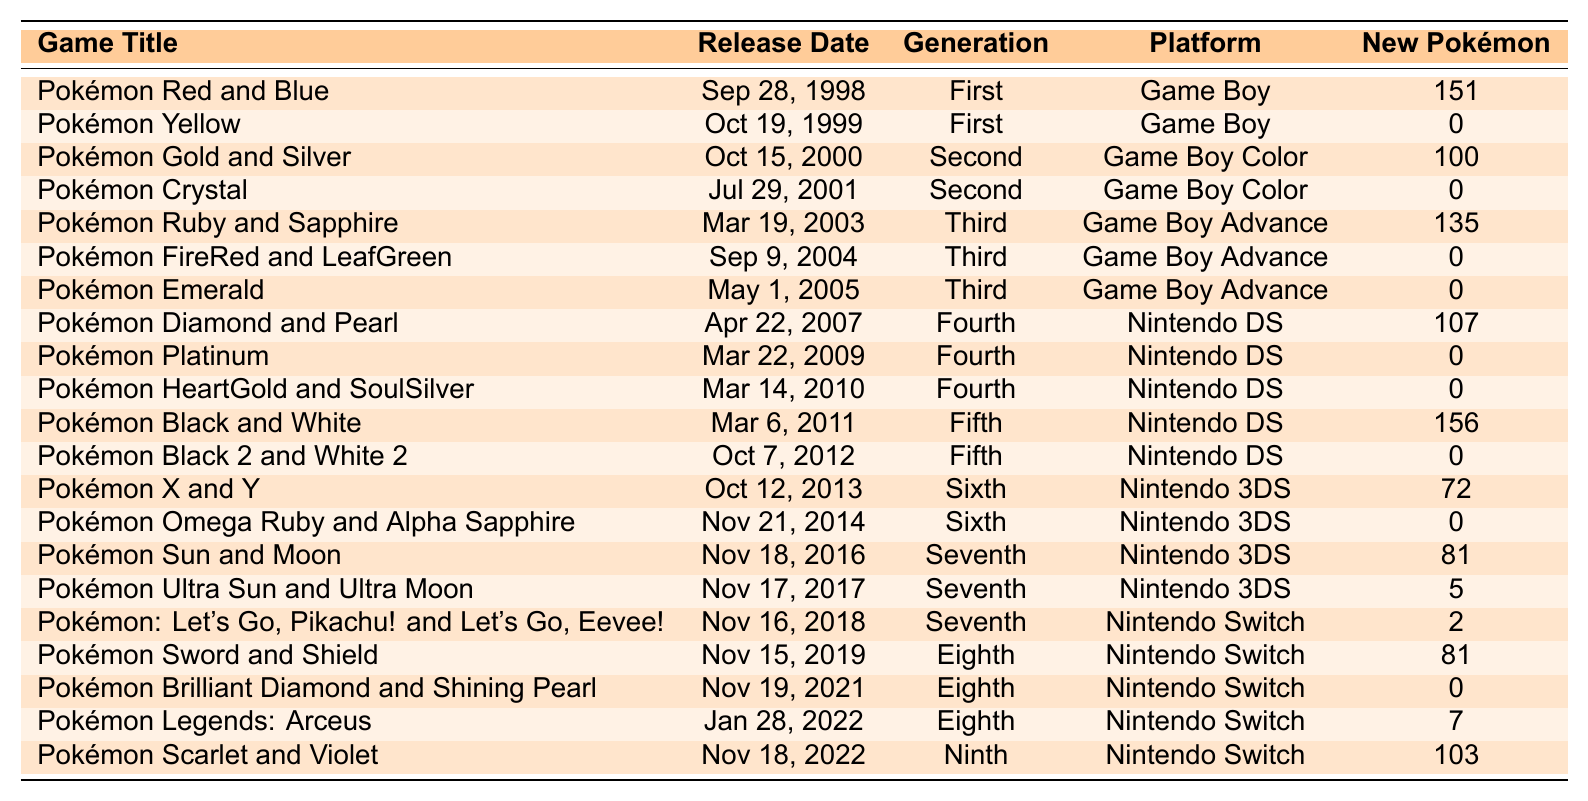What is the release date of Pokémon Gold and Silver? The release date can be found in the table under the "Release Date" column for the row containing "Pokémon Gold and Silver." It states October 15, 2000.
Answer: October 15, 2000 How many new Pokémon were introduced in Pokémon Black and White? Looking under the "New Pokémon" column for the row corresponding to "Pokémon Black and White," it shows the value 156.
Answer: 156 Which game was released first: Pokémon Sword and Shield or Pokémon Brilliant Diamond and Shining Pearl? To determine which game was released first, compare their release dates listed in the table: Pokémon Sword and Shield was released on November 15, 2019, while Pokémon Brilliant Diamond and Shining Pearl was released on November 19, 2021. Since November 2019 is earlier than November 2021, Pokémon Sword and Shield was released first.
Answer: Pokémon Sword and Shield What is the total number of new Pokémon introduced by Pokémon Ruby and Sapphire and Pokémon Diamond and Pearl combined? First, find the number of new Pokémon introduced in each game. For Pokémon Ruby and Sapphire, it is 135, and for Pokémon Diamond and Pearl, it is 107. Adding these two values gives: 135 + 107 = 242.
Answer: 242 In which generation was Pokémon Legends: Arceus released? Looking at the "Generation" column corresponding to the row for "Pokémon Legends: Arceus," it indicates it is part of the Eighth generation.
Answer: Eighth generation Is it true that all the games in the Third generation introduced new Pokémon? To determine this, check each game's "New Pokémon" count in the "Third" generation (Pokémon Ruby and Sapphire, FireRed and LeafGreen, and Emerald). FireRed and LeafGreen and Emerald both have a new Pokémon count of 0. Therefore, it's false that all Third generation games introduced new Pokémon.
Answer: No What is the difference in the number of new Pokémon between Pokémon X and Y and Pokémon Sun and Moon? First, find the new Pokémon counts for each game: Pokémon X and Y has 72, while Pokémon Sun and Moon has 81. To find the difference, subtract the counts: 81 - 72 = 9.
Answer: 9 Which game has the least number of new Pokémon introduced? In the "New Pokémon" column, observe the values to find the minimum. Pokémon Yellow, Pokémon Crystal, Pokémon FireRed and LeafGreen, Pokémon Platinum, Pokémon HeartGold and SoulSilver, Pokémon Black 2 and White 2, and Pokémon Brilliant Diamond and Shining Pearl, all introduced 0 new Pokémon, making them the games with the least.
Answer: Multiple games (0 new Pokémon) What is the average number of new Pokémon introduced per generation? To calculate the average, sum the total number of new Pokémon across all games and then divide by the number of games shown in the table. The sum is calculated as follows: 151 + 0 + 100 + 0 + 135 + 0 + 0 + 107 + 0 + 0 + 156 + 0 + 72 + 0 + 81 + 5 + 2 + 81 + 0 + 7 + 103 = 576. There are 22 games total, so the average is 576 / 22 ≈ 26.18.
Answer: Approximately 26.18 